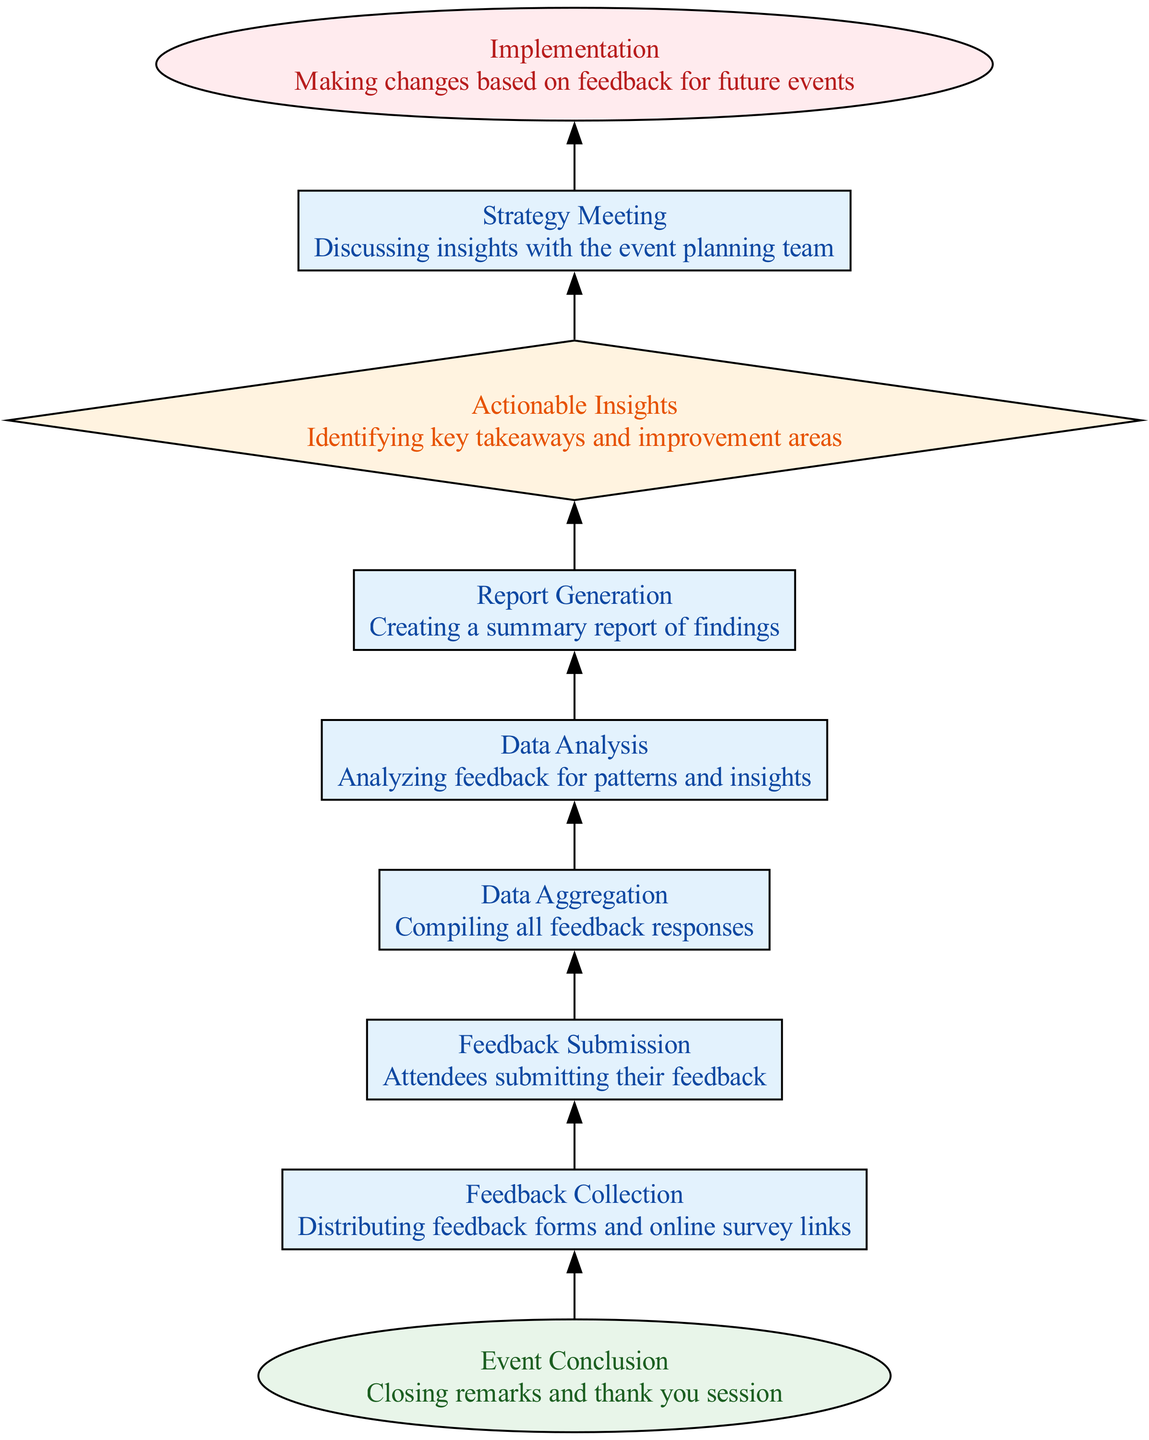What is the first step in the workflow? The workflow starts with "Event Conclusion," which is the initial node where closing remarks and thank you sessions take place.
Answer: Event Conclusion How many total nodes are in the diagram? The diagram consists of 9 distinct nodes, including start, processes, decisions, and end nodes, which outline the entire feedback workflow.
Answer: 9 What type of node is "Feedback Collection"? "Feedback Collection" is categorized as a process node, indicated by a rectangle shape and its function of distributing feedback forms and online survey links.
Answer: process Which node comes directly after "Data Analysis"? "Report Generation" directly follows "Data Analysis" in the workflow, representing the step where a summary report of findings is created.
Answer: Report Generation What step follows after "Actionable Insights"? After "Actionable Insights," the next step is "Strategy Meeting," where insights are discussed with the event planning team to evaluate the feedback.
Answer: Strategy Meeting What is the final outcome of the workflow? The final outcome of the workflow is represented by the "Implementation" node, indicating that changes will be made based on feedback for future events.
Answer: Implementation Which nodes are categorized as 'process' types? The nodes categorized as 'process' types include "Feedback Collection," "Feedback Submission," "Data Aggregation," "Data Analysis," "Report Generation," and "Strategy Meeting."
Answer: Feedback Collection, Feedback Submission, Data Aggregation, Data Analysis, Report Generation, Strategy Meeting How are the nodes connected? The nodes are connected in a sequential manner, with each node leading to the next step in the feedback workflow, starting from "Event Conclusion" and ending at "Implementation."
Answer: Sequentially What decision needs to be made in the workflow? The decision point occurs at "Actionable Insights," where key takeaways and improvement areas are identified based on the analyzed feedback.
Answer: Actionable Insights 